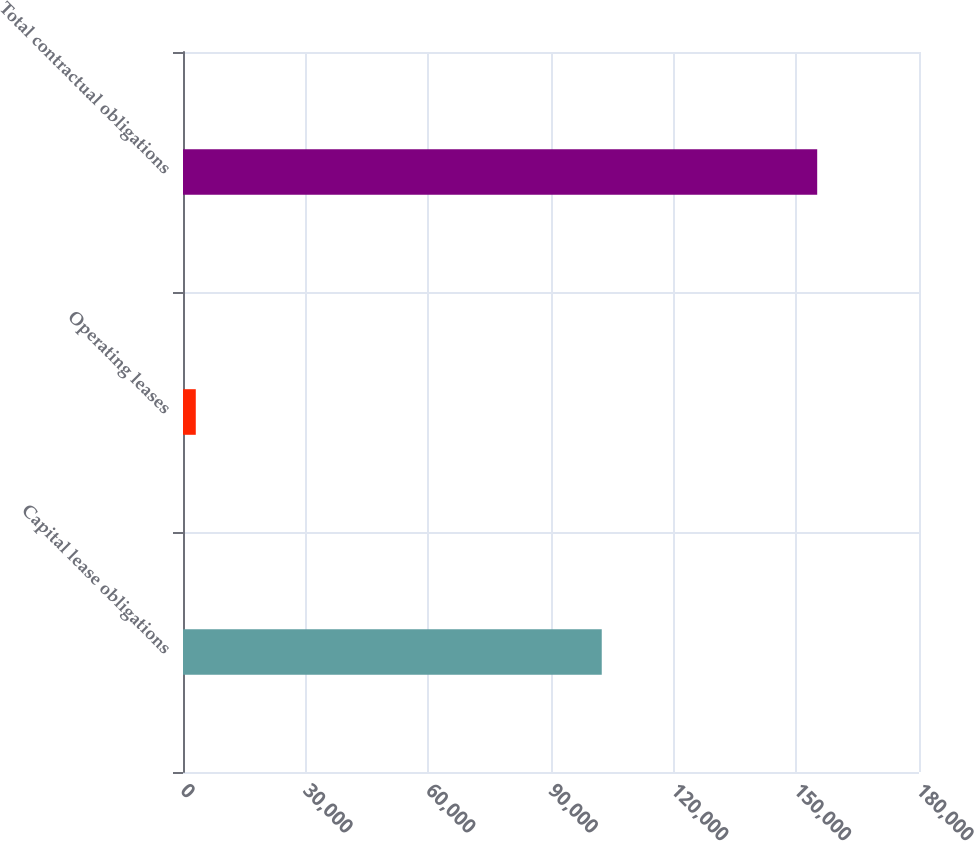<chart> <loc_0><loc_0><loc_500><loc_500><bar_chart><fcel>Capital lease obligations<fcel>Operating leases<fcel>Total contractual obligations<nl><fcel>102411<fcel>3125<fcel>155103<nl></chart> 